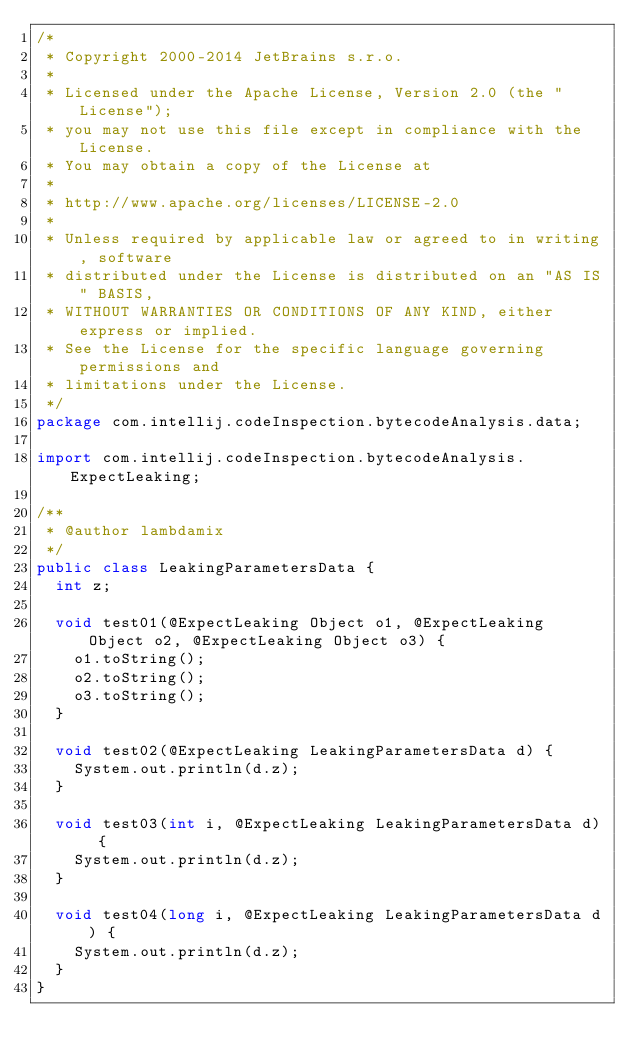Convert code to text. <code><loc_0><loc_0><loc_500><loc_500><_Java_>/*
 * Copyright 2000-2014 JetBrains s.r.o.
 *
 * Licensed under the Apache License, Version 2.0 (the "License");
 * you may not use this file except in compliance with the License.
 * You may obtain a copy of the License at
 *
 * http://www.apache.org/licenses/LICENSE-2.0
 *
 * Unless required by applicable law or agreed to in writing, software
 * distributed under the License is distributed on an "AS IS" BASIS,
 * WITHOUT WARRANTIES OR CONDITIONS OF ANY KIND, either express or implied.
 * See the License for the specific language governing permissions and
 * limitations under the License.
 */
package com.intellij.codeInspection.bytecodeAnalysis.data;

import com.intellij.codeInspection.bytecodeAnalysis.ExpectLeaking;

/**
 * @author lambdamix
 */
public class LeakingParametersData {
  int z;

  void test01(@ExpectLeaking Object o1, @ExpectLeaking Object o2, @ExpectLeaking Object o3) {
    o1.toString();
    o2.toString();
    o3.toString();
  }

  void test02(@ExpectLeaking LeakingParametersData d) {
    System.out.println(d.z);
  }

  void test03(int i, @ExpectLeaking LeakingParametersData d) {
    System.out.println(d.z);
  }

  void test04(long i, @ExpectLeaking LeakingParametersData d) {
    System.out.println(d.z);
  }
}
</code> 